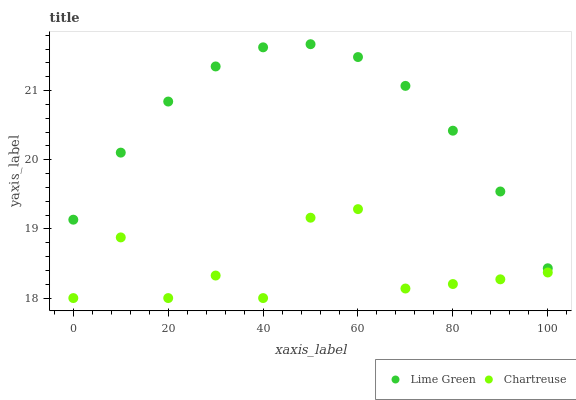Does Chartreuse have the minimum area under the curve?
Answer yes or no. Yes. Does Lime Green have the maximum area under the curve?
Answer yes or no. Yes. Does Lime Green have the minimum area under the curve?
Answer yes or no. No. Is Lime Green the smoothest?
Answer yes or no. Yes. Is Chartreuse the roughest?
Answer yes or no. Yes. Is Lime Green the roughest?
Answer yes or no. No. Does Chartreuse have the lowest value?
Answer yes or no. Yes. Does Lime Green have the lowest value?
Answer yes or no. No. Does Lime Green have the highest value?
Answer yes or no. Yes. Is Chartreuse less than Lime Green?
Answer yes or no. Yes. Is Lime Green greater than Chartreuse?
Answer yes or no. Yes. Does Chartreuse intersect Lime Green?
Answer yes or no. No. 